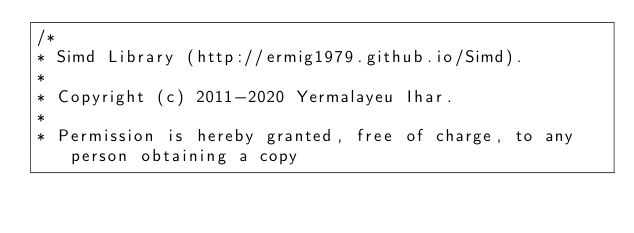Convert code to text. <code><loc_0><loc_0><loc_500><loc_500><_C++_>/*
* Simd Library (http://ermig1979.github.io/Simd).
*
* Copyright (c) 2011-2020 Yermalayeu Ihar.
*
* Permission is hereby granted, free of charge, to any person obtaining a copy</code> 